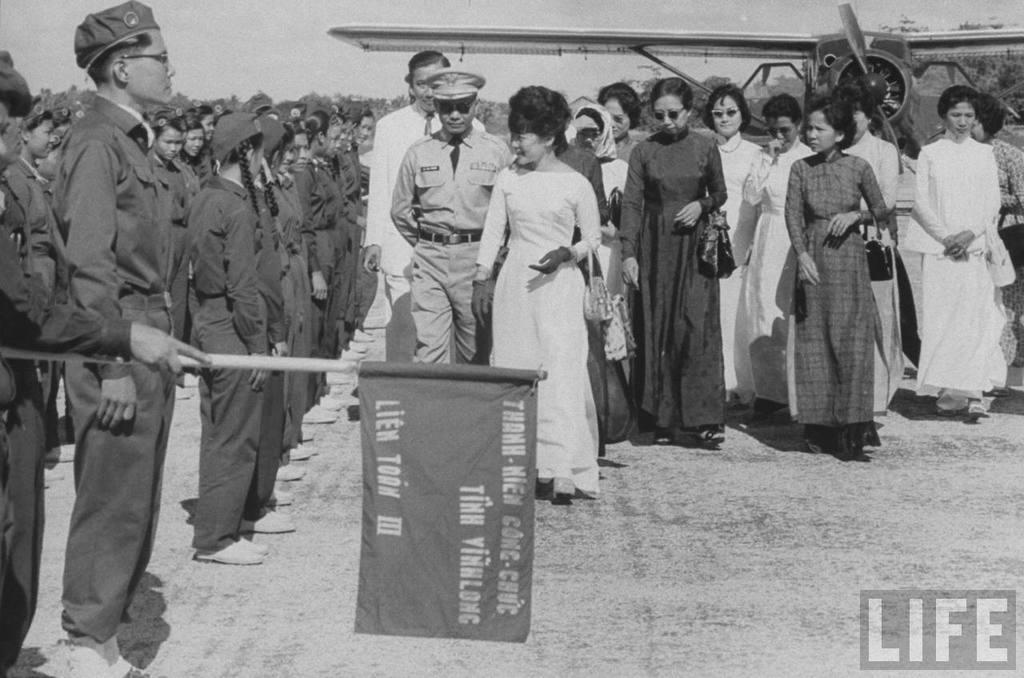<image>
Share a concise interpretation of the image provided. soldiers and women in a LIFE photo by a plane and Vietnamese flag 